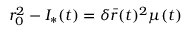Convert formula to latex. <formula><loc_0><loc_0><loc_500><loc_500>r _ { 0 } ^ { 2 } - I _ { * } ( t ) = \delta \bar { r } ( t ) ^ { 2 } \mu ( t )</formula> 